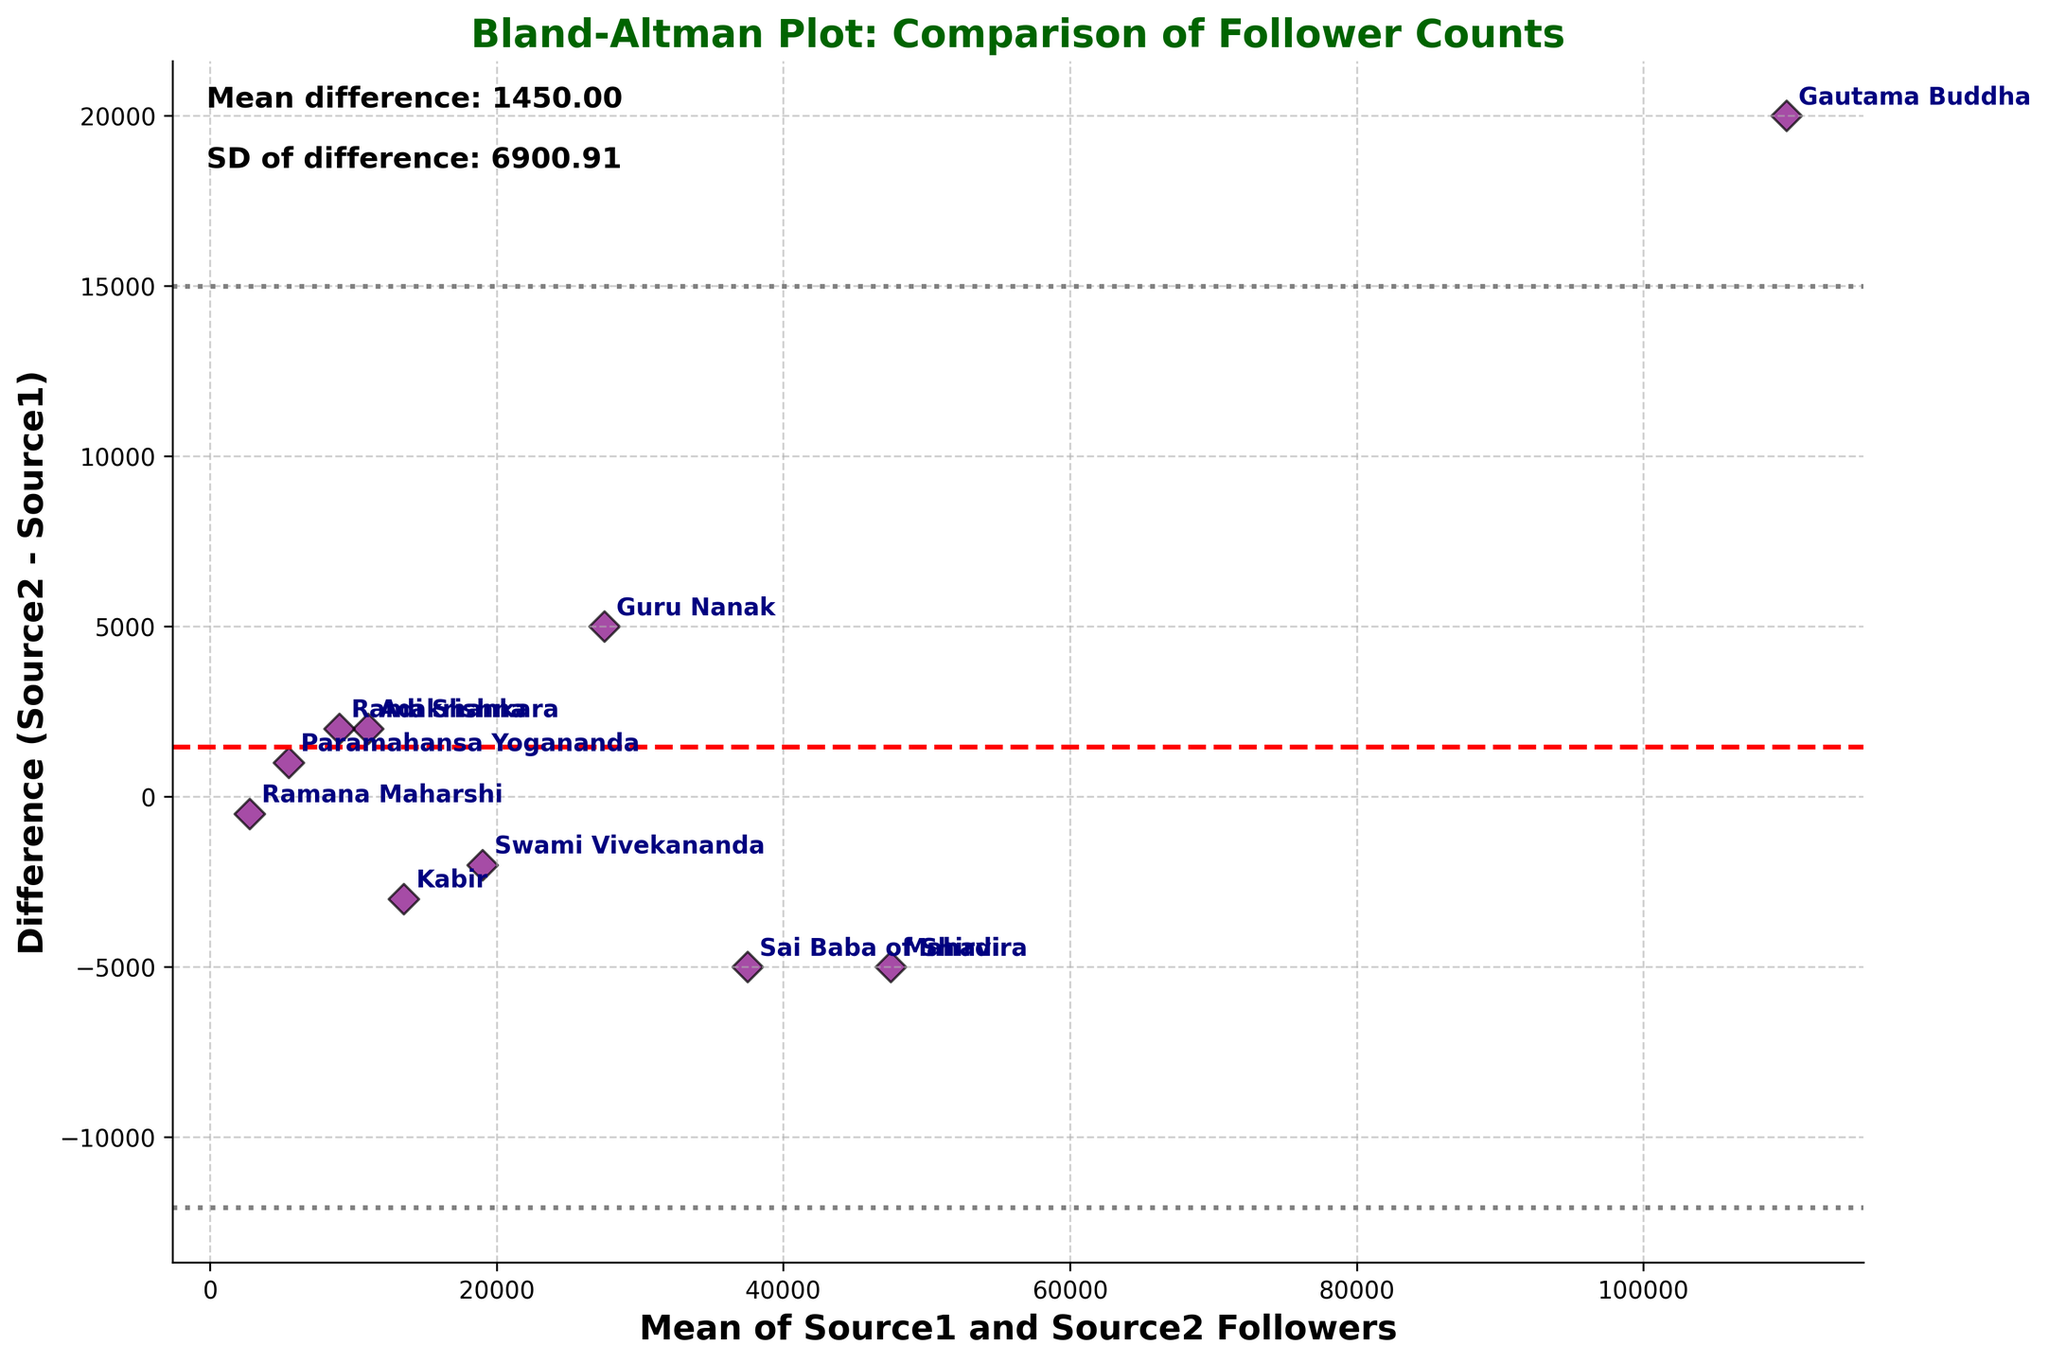What's the title of the plot? The title of the plot is located at the top, usually in a larger and bold font which makes it easy to identify.
Answer: Bland-Altman Plot: Comparison of Follower Counts What does the x-axis represent? The x-axis label is 'Mean of Source1 and Source2 Followers', indicating it represents the average number of followers from both sources.
Answer: Mean of Source1 and Source2 Followers What does the y-axis represent? The y-axis label is 'Difference (Source2 - Source1)', indicating it represents the difference in follower counts between Source2 and Source1.
Answer: Difference (Source2 - Source1) Which guru has the highest average number of followers? To find this, look for the point farthest to the right, as it has the highest mean value on the x-axis, which represents the average number of followers. This point corresponds to Gautama Buddha.
Answer: Gautama Buddha Which guru has the largest difference in follower counts between the two sources? Look for the point farthest from the x-axis (mean difference), regardless of it being above or below. Gautama Buddha has the largest difference.
Answer: Gautama Buddha What is the mean difference in follower counts between the two sources? The mean difference is denoted by the dashed red line parallel to the x-axis, and the value is mentioned in the text annotation. The mean difference is given as 1400.00.
Answer: 1400.00 What is the standard deviation of the differences in follower counts? The standard deviation is mentioned in the text annotations within the plot. The standard deviation is given as 9360.41.
Answer: 9360.41 Which guru has the smallest difference in follower counts between the two sources? Identify the point closest to the horizontal red dashed line, which represents the mean difference. Paramahansa Yogananda's point appears to be closest to this line.
Answer: Paramahansa Yogananda Are there any gurus for whom Source1 records more followers than Source2? Look for points below the zero line on the y-axis (where Source2 - Source1 is negative). Kabir, Sai Baba of Shirdi, Swami Vivekananda, Ramana Maharshi, and Mahavira fall below zero, indicating Source1 records more followers for them.
Answer: Yes Which gurus have a difference in followers outside the limits of agreement? Limits of agreement are marked by the gray dashed lines (+1.96*SD and -1.96*SD). Identify the points outside these lines. No points appear outside these limits of agreement.
Answer: None 